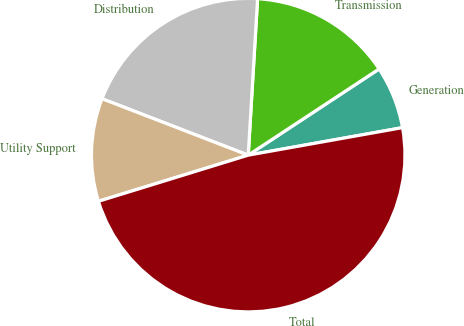<chart> <loc_0><loc_0><loc_500><loc_500><pie_chart><fcel>Generation<fcel>Transmission<fcel>Distribution<fcel>Utility Support<fcel>Total<nl><fcel>6.46%<fcel>14.78%<fcel>20.09%<fcel>10.62%<fcel>48.06%<nl></chart> 